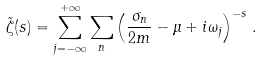<formula> <loc_0><loc_0><loc_500><loc_500>\tilde { \zeta } ( s ) = \sum _ { j = - \infty } ^ { + \infty } \sum _ { n } \left ( \frac { \sigma _ { n } } { 2 m } - \mu + i \omega _ { j } \right ) ^ { - s } \, .</formula> 